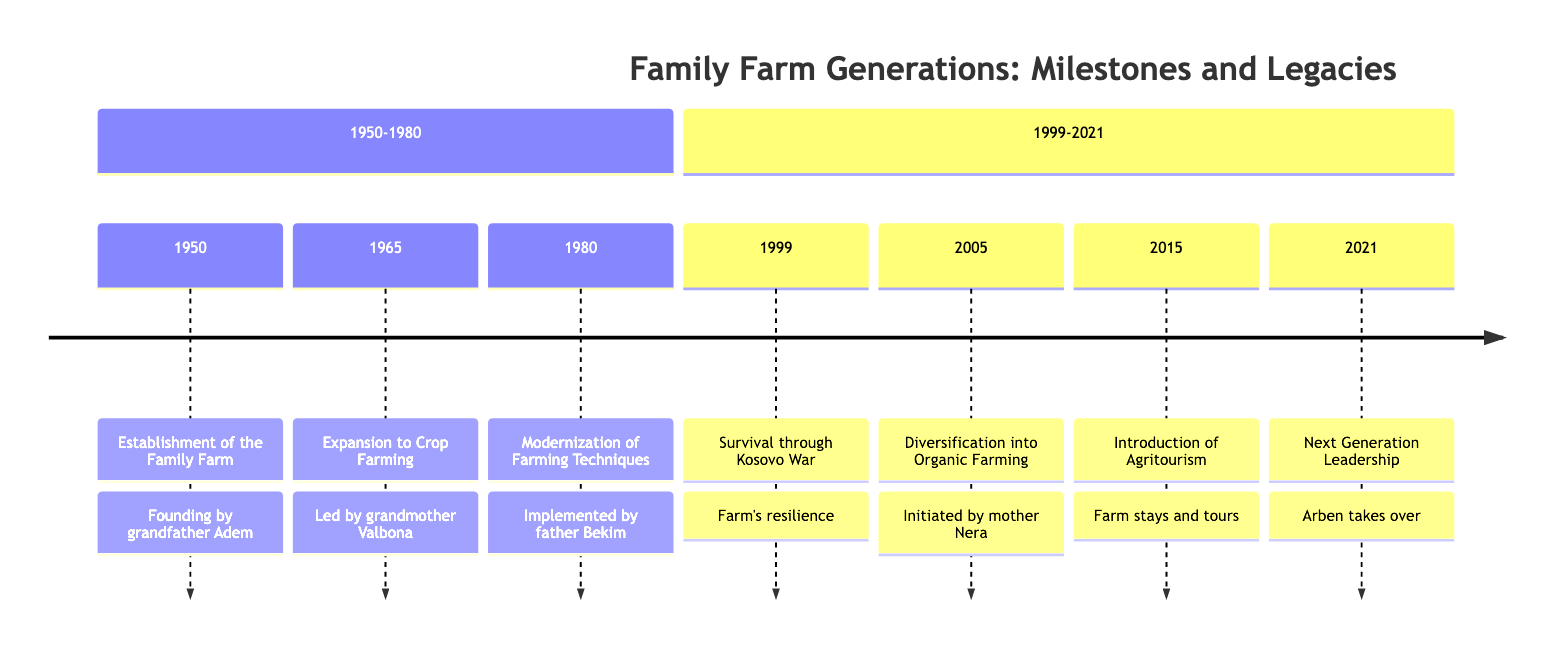What year was the family farm established? The diagram shows the establishment of the family farm occurring in 1950. This is marked as the first event in the timeline.
Answer: 1950 Who led the expansion to crop farming? According to the diagram, the expansion to crop farming in 1965 was led by grandmother Valbona, as indicated in the event description.
Answer: grandmother Valbona How many major events are listed between 1950 and 1980? Counting the events listed in the section from 1950 to 1980, there are three major events: establishment, expansion, and modernization of farming techniques.
Answer: 3 What significant event occurred in 1999? The significant event in 1999 is the survival of the farm during the Kosovo War, which is noted in the timeline.
Answer: Survival through Kosovo War Who initiated the transition to organic farming? The transition to organic farming was initiated by mother Nera in the year 2005, as noted in the timeline description.
Answer: mother Nera Which event marks the introduction of agritourism? The introduction of agritourism is marked by the event in 2015 in the timeline, where it is described as the launch of initiatives for farm stays and educational tours.
Answer: Introduction of Agritourism In what year did the eldest son take over management? The eldest son, Arben, took over management in 2021, which is specified as the final event in the timeline.
Answer: 2021 What farming technique change occurred in 1980? The change in farming technique that occurred in 1980 was the modernization of farming techniques implemented by father Bekim, as depicted in the event description.
Answer: Modernization of Farming Techniques Which two events show the farm’s resilience? The events demonstrating the farm’s resilience are the survival through the Kosovo War in 1999 and the continued growth through diversification into organic farming in 2005. Both illustrate resilience against challenges.
Answer: Survival through Kosovo War, Diversification into Organic Farming 